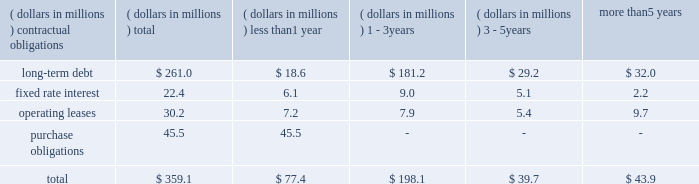In december , our board of directors ratified its authorization of a stock repurchase program in the amount of 1.5 million shares of our common stock .
As of december 31 , 2010 no shares had been repurchased .
We have paid dividends for 71 consecutive years with payments increasing each of the last 19 years .
We paid total dividends of $ .54 per share in 2010 compared with $ .51 per share in 2009 .
Aggregate contractual obligations a summary of our contractual obligations as of december 31 , 2010 , is as follows: .
As of december 31 , 2010 , the liability for uncertain income tax positions was $ 2.7 million .
Due to the high degree of uncertainty regarding timing of potential future cash flows associated with these liabilities , we are unable to make a reasonably reliable estimate of the amount and period in which these liabilities might be paid .
We utilize blanket purchase orders to communicate expected annual requirements to many of our suppliers .
Requirements under blanket purchase orders generally do not become committed until several weeks prior to the company 2019s scheduled unit production .
The purchase obligation amount presented above represents the value of commitments considered firm .
Results of operations our sales from continuing operations in 2010 were $ 1489.3 million surpassing 2009 sales of $ 1375.0 million by 8.3 percent .
The increase in sales was due mostly to significantly higher sales in our water heater operations in china resulting from geographic expansion , market share gains and new product introductions as well as additional sales from our water treatment business acquired in november , 2009 .
Our sales from continuing operations were $ 1451.3 million in 2008 .
The $ 76.3 million decline in sales from 2008 to 2009 was due to lower residential and commercial volume in north america , reflecting softness in the domestic housing market and a slowdown in the commercial water heater business and was partially offset by strong growth in water heater sales in china and improved year over year pricing .
On december 13 , 2010 we entered into a definitive agreement to sell our electrical products company to regal beloit corporation for $ 700 million in cash and approximately 2.83 million shares of regal beloit common stock .
The transaction , which has been approved by both companies' board of directors , is expected to close in the first half of 2011 .
Due to the pending sale , our electrical products segment has been accorded discontinued operations treatment in the accompanying financial statements .
Sales in 2010 , including sales of $ 701.8 million for our electrical products segment , were $ 2191.1 million .
Our gross profit margin for continuing operations in 2010 was 29.9 percent , compared with 28.7 percent in 2009 and 25.8 percent in 2008 .
The improvement in margin from 2009 to 2010 was due to increased volume , cost containment activities and lower warranty costs which more than offset certain inefficiencies resulting from the may flood in our ashland city , tn water heater manufacturing facility .
The increase in profit margin from 2008 to 2009 resulted from increased higher margin china water heater volume , aggressive cost reduction programs and lower material costs .
Selling , general and administrative expense ( sg&a ) was $ 36.9 million higher in 2010 than in 2009 .
The increased sg&a , the majority of which was incurred in our china water heater operation , was associated with selling costs to support higher volume and new product lines .
Additional sg&a associated with our 2009 water treatment acquisition also contributed to the increase .
Sg&a was $ 8.5 million higher in 2009 than 2008 resulting mostly from an $ 8.2 million increase in our china water heater operation in support of higher volumes. .
What percentage of total aggregate contractual obligations is composed of ? 
Computations: (45.5 / 359.1)
Answer: 0.12671. 